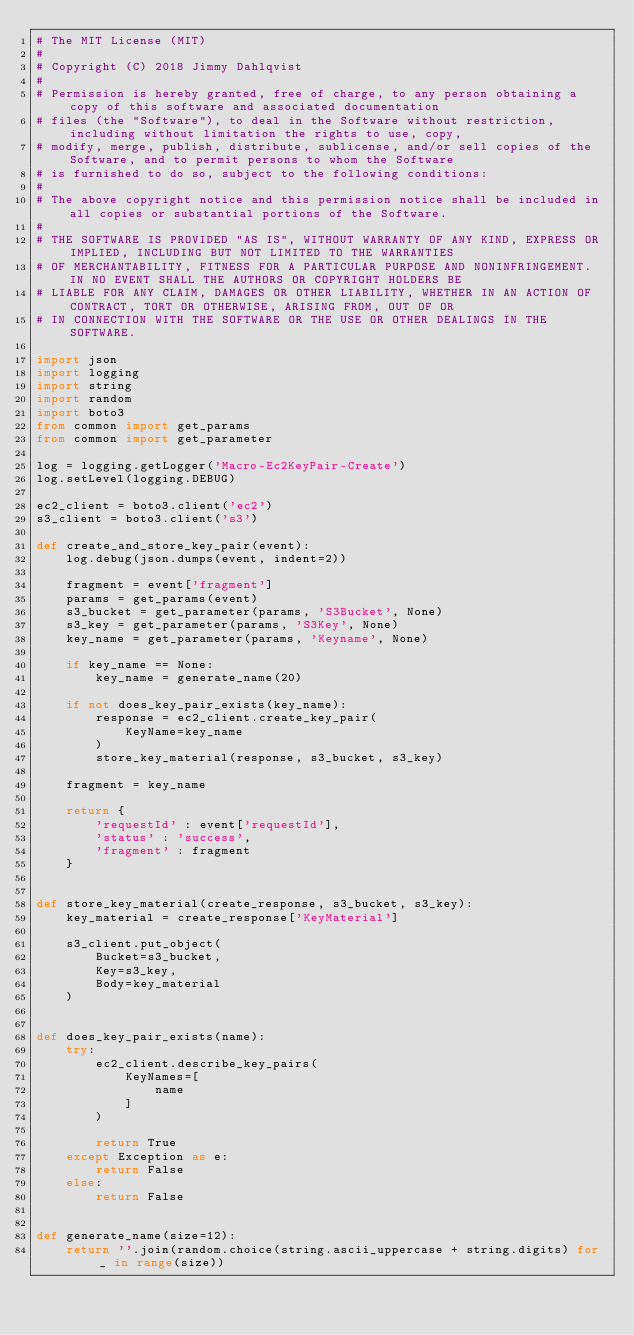<code> <loc_0><loc_0><loc_500><loc_500><_Python_># The MIT License (MIT)
#
# Copyright (C) 2018 Jimmy Dahlqvist
#
# Permission is hereby granted, free of charge, to any person obtaining a copy of this software and associated documentation
# files (the "Software"), to deal in the Software without restriction, including without limitation the rights to use, copy,
# modify, merge, publish, distribute, sublicense, and/or sell copies of the Software, and to permit persons to whom the Software
# is furnished to do so, subject to the following conditions:
#
# The above copyright notice and this permission notice shall be included in all copies or substantial portions of the Software.
#
# THE SOFTWARE IS PROVIDED "AS IS", WITHOUT WARRANTY OF ANY KIND, EXPRESS OR IMPLIED, INCLUDING BUT NOT LIMITED TO THE WARRANTIES
# OF MERCHANTABILITY, FITNESS FOR A PARTICULAR PURPOSE AND NONINFRINGEMENT. IN NO EVENT SHALL THE AUTHORS OR COPYRIGHT HOLDERS BE
# LIABLE FOR ANY CLAIM, DAMAGES OR OTHER LIABILITY, WHETHER IN AN ACTION OF CONTRACT, TORT OR OTHERWISE, ARISING FROM, OUT OF OR
# IN CONNECTION WITH THE SOFTWARE OR THE USE OR OTHER DEALINGS IN THE SOFTWARE.

import json
import logging
import string
import random
import boto3
from common import get_params
from common import get_parameter

log = logging.getLogger('Macro-Ec2KeyPair-Create')
log.setLevel(logging.DEBUG)

ec2_client = boto3.client('ec2')
s3_client = boto3.client('s3')

def create_and_store_key_pair(event):
    log.debug(json.dumps(event, indent=2))

    fragment = event['fragment']
    params = get_params(event)
    s3_bucket = get_parameter(params, 'S3Bucket', None)
    s3_key = get_parameter(params, 'S3Key', None)
    key_name = get_parameter(params, 'Keyname', None)
    
    if key_name == None:
        key_name = generate_name(20)

    if not does_key_pair_exists(key_name):
        response = ec2_client.create_key_pair(
            KeyName=key_name
        )
        store_key_material(response, s3_bucket, s3_key)

    fragment = key_name

    return {
        'requestId' : event['requestId'], 
        'status' : 'success', 
        'fragment' : fragment
    }


def store_key_material(create_response, s3_bucket, s3_key):
    key_material = create_response['KeyMaterial']

    s3_client.put_object(
        Bucket=s3_bucket,
        Key=s3_key,
        Body=key_material
    )


def does_key_pair_exists(name):
    try:
        ec2_client.describe_key_pairs(
            KeyNames=[
                name
            ]
        )

        return True
    except Exception as e:
        return False
    else:
        return False


def generate_name(size=12):
    return ''.join(random.choice(string.ascii_uppercase + string.digits) for _ in range(size))
</code> 